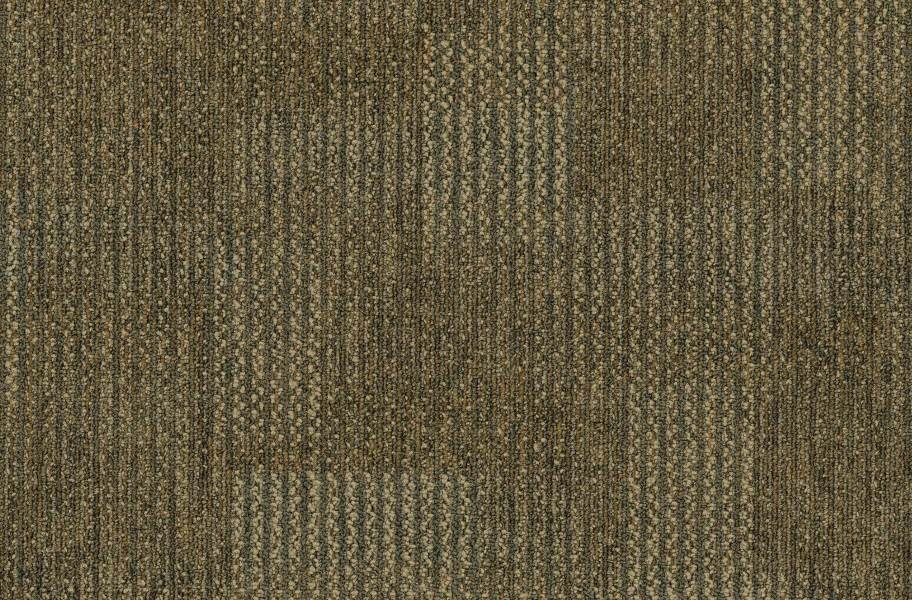What specific purposes might this fabric be used for given its herringbone weave? Given the herringbone weave's excellent durability and resistance to wear, this fabric is particularly well-suited for high-end upholstery, such as sofas and chairs that require both style and longevity. It's also commonly used in outerwear like coats and jackets, where its ability to maintain structure and resist environmental stresses is highly valued. Additionally, its elegant appearance makes it a favored choice for office attire and formal wear. 